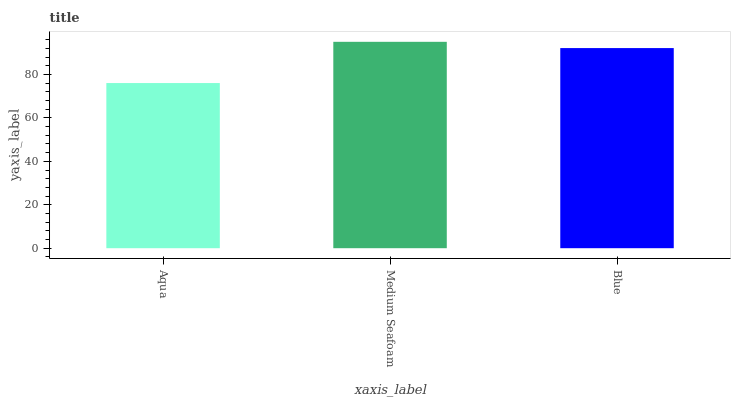Is Aqua the minimum?
Answer yes or no. Yes. Is Medium Seafoam the maximum?
Answer yes or no. Yes. Is Blue the minimum?
Answer yes or no. No. Is Blue the maximum?
Answer yes or no. No. Is Medium Seafoam greater than Blue?
Answer yes or no. Yes. Is Blue less than Medium Seafoam?
Answer yes or no. Yes. Is Blue greater than Medium Seafoam?
Answer yes or no. No. Is Medium Seafoam less than Blue?
Answer yes or no. No. Is Blue the high median?
Answer yes or no. Yes. Is Blue the low median?
Answer yes or no. Yes. Is Aqua the high median?
Answer yes or no. No. Is Medium Seafoam the low median?
Answer yes or no. No. 